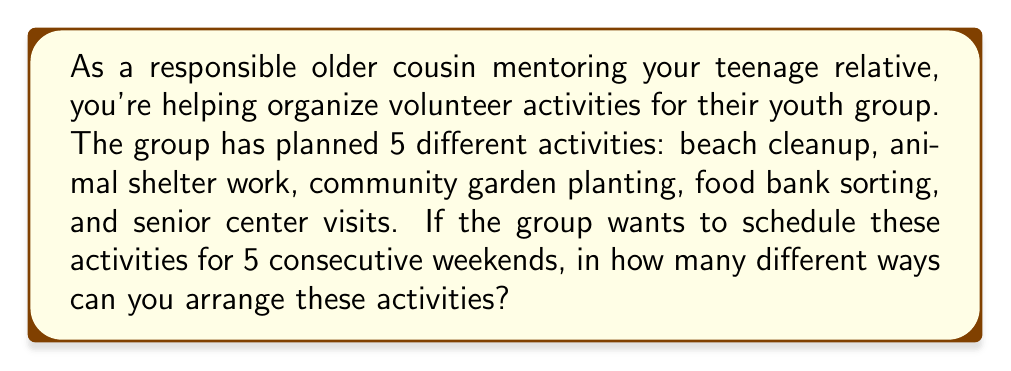Give your solution to this math problem. Let's approach this step-by-step:

1) We have 5 different activities that need to be arranged in a specific order for 5 weekends.

2) This is a perfect scenario for using permutations. We're arranging all 5 activities (using each one exactly once) in a specific order.

3) The formula for permutations of n distinct objects is:

   $$P(n) = n!$$

   Where $n!$ represents the factorial of $n$.

4) In this case, $n = 5$ (as we have 5 activities to arrange).

5) Therefore, we need to calculate:

   $$P(5) = 5!$$

6) Let's expand this:
   
   $$5! = 5 \times 4 \times 3 \times 2 \times 1 = 120$$

7) This means there are 120 different ways to arrange these 5 activities over 5 weekends.

8) To break it down further:
   - For the first weekend, we have 5 choices of activities
   - For the second weekend, we have 4 remaining choices
   - For the third weekend, we have 3 remaining choices
   - For the fourth weekend, we have 2 remaining choices
   - For the last weekend, we only have 1 activity left

   $5 \times 4 \times 3 \times 2 \times 1 = 120$

This calculation ensures that each activity is used once and only once, which fits our scenario perfectly.
Answer: 120 ways 